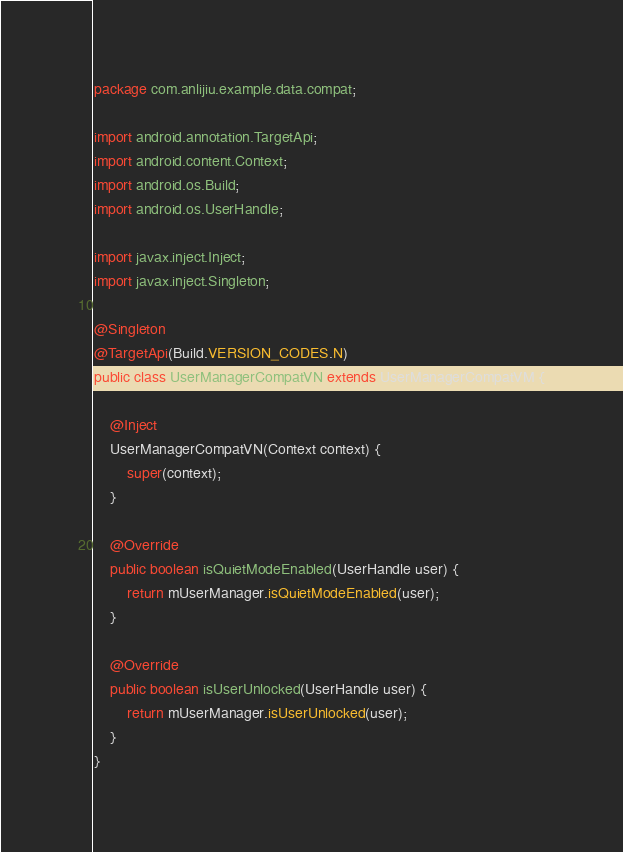<code> <loc_0><loc_0><loc_500><loc_500><_Java_>package com.anlijiu.example.data.compat;

import android.annotation.TargetApi;
import android.content.Context;
import android.os.Build;
import android.os.UserHandle;

import javax.inject.Inject;
import javax.inject.Singleton;

@Singleton
@TargetApi(Build.VERSION_CODES.N)
public class UserManagerCompatVN extends UserManagerCompatVM {

    @Inject
    UserManagerCompatVN(Context context) {
        super(context);
    }

    @Override
    public boolean isQuietModeEnabled(UserHandle user) {
        return mUserManager.isQuietModeEnabled(user);
    }

    @Override
    public boolean isUserUnlocked(UserHandle user) {
        return mUserManager.isUserUnlocked(user);
    }
}

</code> 